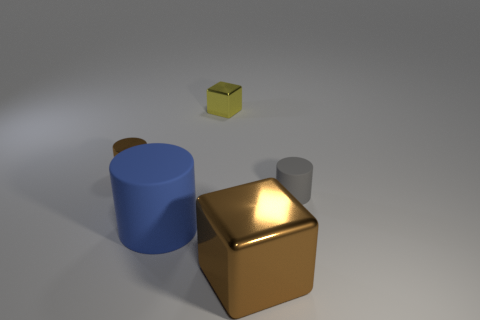Is there a shiny cylinder that has the same color as the large block?
Make the answer very short. Yes. Is the number of tiny gray matte things that are behind the tiny yellow block the same as the number of yellow metal balls?
Give a very brief answer. Yes. Do the tiny metallic cylinder and the small rubber object have the same color?
Provide a succinct answer. No. There is a object that is both in front of the small gray thing and to the right of the big rubber object; how big is it?
Make the answer very short. Large. The cylinder that is made of the same material as the big cube is what color?
Keep it short and to the point. Brown. What number of brown blocks are the same material as the yellow block?
Offer a terse response. 1. Are there the same number of yellow things in front of the tiny brown thing and small things that are on the right side of the big brown object?
Your response must be concise. No. There is a big rubber object; is its shape the same as the tiny object in front of the brown metallic cylinder?
Keep it short and to the point. Yes. Is there anything else that has the same shape as the large blue matte thing?
Keep it short and to the point. Yes. Does the big brown thing have the same material as the small cylinder behind the gray cylinder?
Offer a terse response. Yes. 